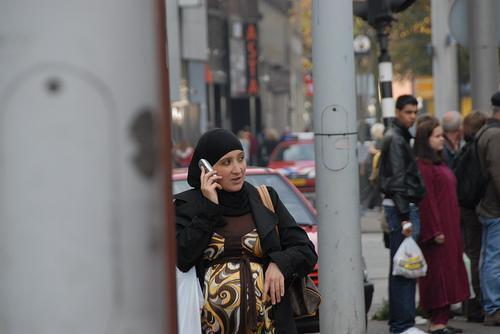How many people are on their phones?
Give a very brief answer. 1. How many cars can you see?
Give a very brief answer. 2. How many people can you see?
Give a very brief answer. 4. 